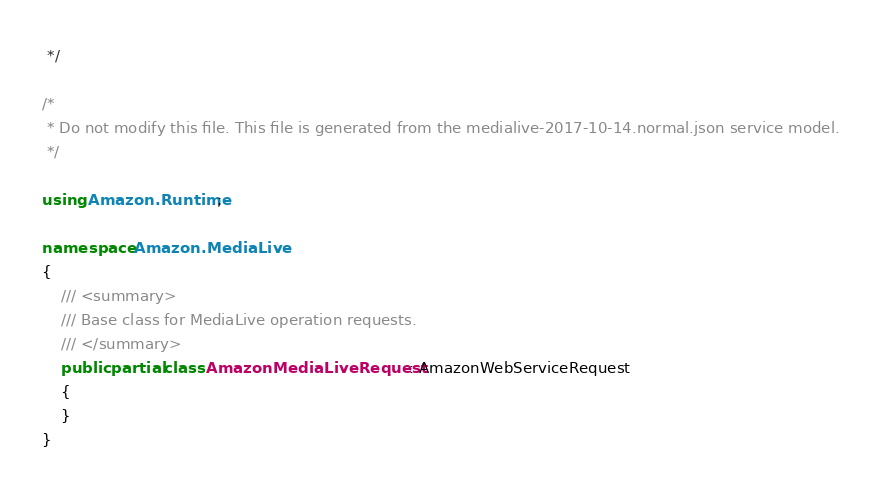Convert code to text. <code><loc_0><loc_0><loc_500><loc_500><_C#_> */

/*
 * Do not modify this file. This file is generated from the medialive-2017-10-14.normal.json service model.
 */

using Amazon.Runtime;

namespace Amazon.MediaLive
{
    /// <summary>
    /// Base class for MediaLive operation requests.
    /// </summary>
    public partial class AmazonMediaLiveRequest : AmazonWebServiceRequest
    {
    }
}</code> 